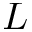Convert formula to latex. <formula><loc_0><loc_0><loc_500><loc_500>L</formula> 